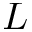Convert formula to latex. <formula><loc_0><loc_0><loc_500><loc_500>L</formula> 